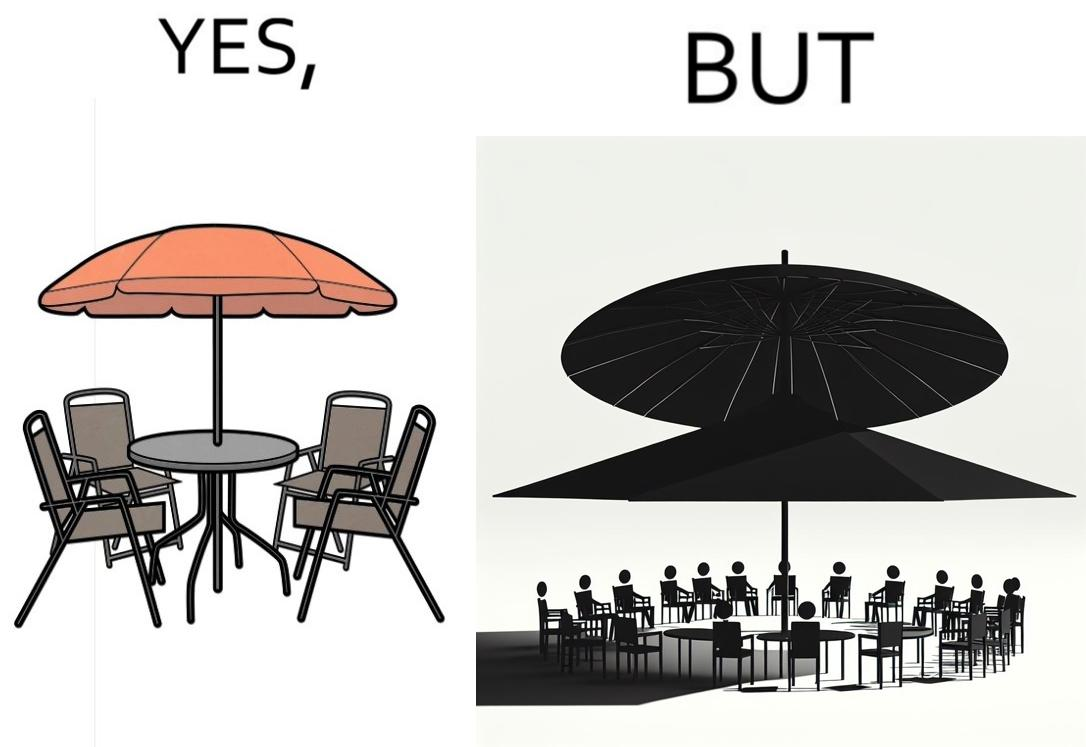Describe the content of this image. The image is ironical, as the umbrella is meant to provide shadow in the area where the chairs are present, but due to the orientation of the rays of the sun, all the chairs are in sunlight, and the umbrella is of no use in this situation. 